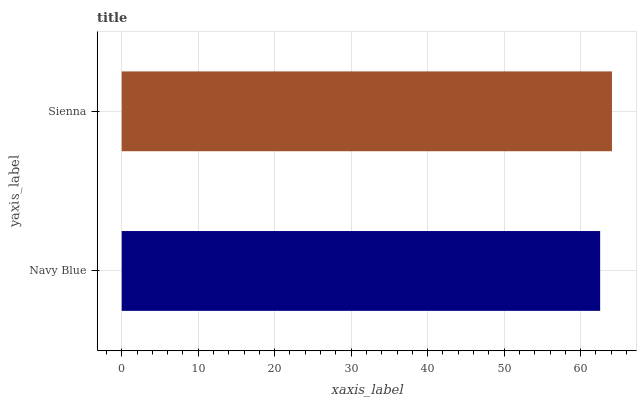Is Navy Blue the minimum?
Answer yes or no. Yes. Is Sienna the maximum?
Answer yes or no. Yes. Is Sienna the minimum?
Answer yes or no. No. Is Sienna greater than Navy Blue?
Answer yes or no. Yes. Is Navy Blue less than Sienna?
Answer yes or no. Yes. Is Navy Blue greater than Sienna?
Answer yes or no. No. Is Sienna less than Navy Blue?
Answer yes or no. No. Is Sienna the high median?
Answer yes or no. Yes. Is Navy Blue the low median?
Answer yes or no. Yes. Is Navy Blue the high median?
Answer yes or no. No. Is Sienna the low median?
Answer yes or no. No. 